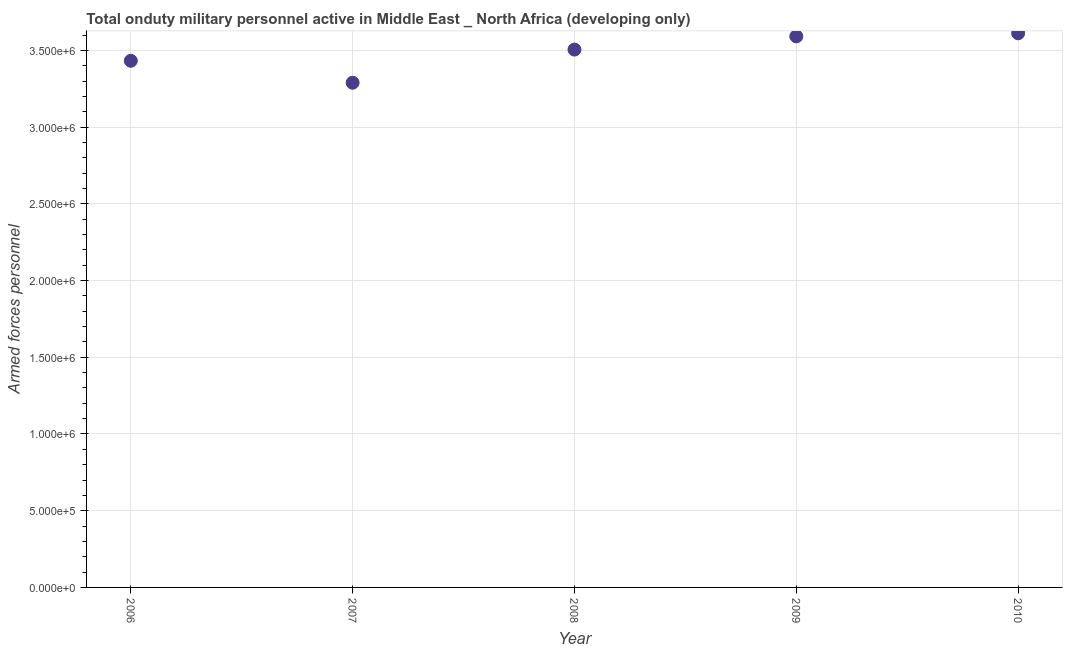What is the number of armed forces personnel in 2008?
Give a very brief answer. 3.50e+06. Across all years, what is the maximum number of armed forces personnel?
Give a very brief answer. 3.61e+06. Across all years, what is the minimum number of armed forces personnel?
Give a very brief answer. 3.29e+06. In which year was the number of armed forces personnel maximum?
Provide a succinct answer. 2010. In which year was the number of armed forces personnel minimum?
Your answer should be very brief. 2007. What is the sum of the number of armed forces personnel?
Your answer should be very brief. 1.74e+07. What is the difference between the number of armed forces personnel in 2006 and 2010?
Give a very brief answer. -1.79e+05. What is the average number of armed forces personnel per year?
Ensure brevity in your answer.  3.49e+06. What is the median number of armed forces personnel?
Your response must be concise. 3.50e+06. Do a majority of the years between 2009 and 2008 (inclusive) have number of armed forces personnel greater than 3100000 ?
Make the answer very short. No. What is the ratio of the number of armed forces personnel in 2006 to that in 2009?
Provide a succinct answer. 0.96. What is the difference between the highest and the second highest number of armed forces personnel?
Give a very brief answer. 2.00e+04. What is the difference between the highest and the lowest number of armed forces personnel?
Make the answer very short. 3.22e+05. In how many years, is the number of armed forces personnel greater than the average number of armed forces personnel taken over all years?
Offer a very short reply. 3. Does the number of armed forces personnel monotonically increase over the years?
Keep it short and to the point. No. How many dotlines are there?
Ensure brevity in your answer.  1. How many years are there in the graph?
Keep it short and to the point. 5. What is the difference between two consecutive major ticks on the Y-axis?
Give a very brief answer. 5.00e+05. Are the values on the major ticks of Y-axis written in scientific E-notation?
Your answer should be compact. Yes. Does the graph contain any zero values?
Ensure brevity in your answer.  No. Does the graph contain grids?
Your answer should be very brief. Yes. What is the title of the graph?
Keep it short and to the point. Total onduty military personnel active in Middle East _ North Africa (developing only). What is the label or title of the X-axis?
Provide a short and direct response. Year. What is the label or title of the Y-axis?
Provide a succinct answer. Armed forces personnel. What is the Armed forces personnel in 2006?
Your answer should be very brief. 3.43e+06. What is the Armed forces personnel in 2007?
Your answer should be compact. 3.29e+06. What is the Armed forces personnel in 2008?
Provide a succinct answer. 3.50e+06. What is the Armed forces personnel in 2009?
Provide a succinct answer. 3.59e+06. What is the Armed forces personnel in 2010?
Your answer should be compact. 3.61e+06. What is the difference between the Armed forces personnel in 2006 and 2007?
Make the answer very short. 1.43e+05. What is the difference between the Armed forces personnel in 2006 and 2008?
Offer a very short reply. -7.30e+04. What is the difference between the Armed forces personnel in 2006 and 2009?
Your answer should be compact. -1.59e+05. What is the difference between the Armed forces personnel in 2006 and 2010?
Offer a terse response. -1.79e+05. What is the difference between the Armed forces personnel in 2007 and 2008?
Provide a succinct answer. -2.16e+05. What is the difference between the Armed forces personnel in 2007 and 2009?
Ensure brevity in your answer.  -3.02e+05. What is the difference between the Armed forces personnel in 2007 and 2010?
Make the answer very short. -3.22e+05. What is the difference between the Armed forces personnel in 2008 and 2009?
Keep it short and to the point. -8.61e+04. What is the difference between the Armed forces personnel in 2008 and 2010?
Keep it short and to the point. -1.06e+05. What is the difference between the Armed forces personnel in 2009 and 2010?
Your answer should be very brief. -2.00e+04. What is the ratio of the Armed forces personnel in 2006 to that in 2007?
Your answer should be very brief. 1.04. What is the ratio of the Armed forces personnel in 2006 to that in 2008?
Your answer should be compact. 0.98. What is the ratio of the Armed forces personnel in 2006 to that in 2009?
Make the answer very short. 0.96. What is the ratio of the Armed forces personnel in 2007 to that in 2008?
Give a very brief answer. 0.94. What is the ratio of the Armed forces personnel in 2007 to that in 2009?
Provide a succinct answer. 0.92. What is the ratio of the Armed forces personnel in 2007 to that in 2010?
Your answer should be very brief. 0.91. What is the ratio of the Armed forces personnel in 2008 to that in 2009?
Ensure brevity in your answer.  0.98. What is the ratio of the Armed forces personnel in 2009 to that in 2010?
Your answer should be compact. 0.99. 